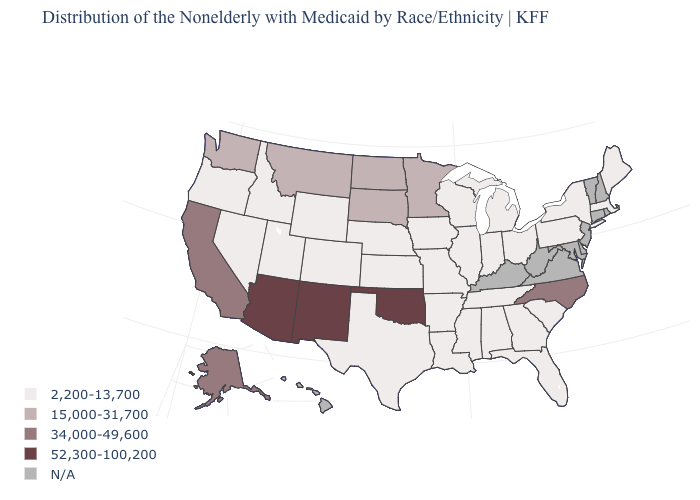Which states have the lowest value in the South?
Quick response, please. Alabama, Arkansas, Florida, Georgia, Louisiana, Mississippi, South Carolina, Tennessee, Texas. What is the value of Michigan?
Write a very short answer. 2,200-13,700. Name the states that have a value in the range 15,000-31,700?
Quick response, please. Minnesota, Montana, North Dakota, South Dakota, Washington. What is the value of North Dakota?
Answer briefly. 15,000-31,700. Does the map have missing data?
Quick response, please. Yes. What is the value of Georgia?
Answer briefly. 2,200-13,700. What is the value of Pennsylvania?
Short answer required. 2,200-13,700. What is the value of New Jersey?
Write a very short answer. N/A. What is the value of Hawaii?
Short answer required. N/A. Which states have the highest value in the USA?
Keep it brief. Arizona, New Mexico, Oklahoma. Which states have the lowest value in the USA?
Concise answer only. Alabama, Arkansas, Colorado, Florida, Georgia, Idaho, Illinois, Indiana, Iowa, Kansas, Louisiana, Maine, Massachusetts, Michigan, Mississippi, Missouri, Nebraska, Nevada, New York, Ohio, Oregon, Pennsylvania, South Carolina, Tennessee, Texas, Utah, Wisconsin, Wyoming. How many symbols are there in the legend?
Concise answer only. 5. Name the states that have a value in the range 52,300-100,200?
Write a very short answer. Arizona, New Mexico, Oklahoma. What is the value of Colorado?
Answer briefly. 2,200-13,700. 